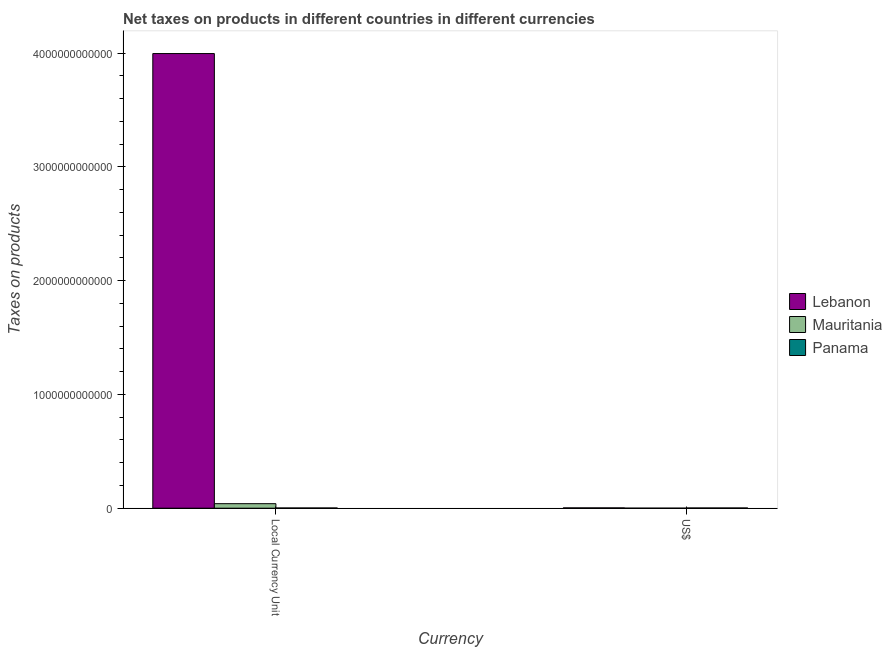Are the number of bars on each tick of the X-axis equal?
Make the answer very short. Yes. What is the label of the 1st group of bars from the left?
Offer a terse response. Local Currency Unit. What is the net taxes in constant 2005 us$ in Lebanon?
Your answer should be compact. 4.00e+12. Across all countries, what is the maximum net taxes in us$?
Your response must be concise. 2.65e+09. Across all countries, what is the minimum net taxes in constant 2005 us$?
Make the answer very short. 1.88e+09. In which country was the net taxes in us$ maximum?
Provide a succinct answer. Lebanon. In which country was the net taxes in us$ minimum?
Offer a very short reply. Mauritania. What is the total net taxes in constant 2005 us$ in the graph?
Offer a terse response. 4.04e+12. What is the difference between the net taxes in us$ in Lebanon and that in Mauritania?
Make the answer very short. 2.50e+09. What is the difference between the net taxes in us$ in Lebanon and the net taxes in constant 2005 us$ in Panama?
Keep it short and to the point. 7.70e+08. What is the average net taxes in constant 2005 us$ per country?
Keep it short and to the point. 1.35e+12. What is the difference between the net taxes in us$ and net taxes in constant 2005 us$ in Mauritania?
Your answer should be very brief. -3.95e+1. What is the ratio of the net taxes in constant 2005 us$ in Mauritania to that in Lebanon?
Provide a succinct answer. 0.01. In how many countries, is the net taxes in us$ greater than the average net taxes in us$ taken over all countries?
Your answer should be compact. 2. What does the 3rd bar from the left in Local Currency Unit represents?
Provide a short and direct response. Panama. What does the 3rd bar from the right in US$ represents?
Your answer should be compact. Lebanon. How many bars are there?
Keep it short and to the point. 6. Are all the bars in the graph horizontal?
Make the answer very short. No. How many countries are there in the graph?
Your response must be concise. 3. What is the difference between two consecutive major ticks on the Y-axis?
Offer a terse response. 1.00e+12. Does the graph contain any zero values?
Your response must be concise. No. Where does the legend appear in the graph?
Provide a succinct answer. Center right. What is the title of the graph?
Ensure brevity in your answer.  Net taxes on products in different countries in different currencies. What is the label or title of the X-axis?
Offer a very short reply. Currency. What is the label or title of the Y-axis?
Make the answer very short. Taxes on products. What is the Taxes on products in Lebanon in Local Currency Unit?
Ensure brevity in your answer.  4.00e+12. What is the Taxes on products of Mauritania in Local Currency Unit?
Offer a very short reply. 3.97e+1. What is the Taxes on products in Panama in Local Currency Unit?
Your answer should be compact. 1.88e+09. What is the Taxes on products of Lebanon in US$?
Make the answer very short. 2.65e+09. What is the Taxes on products in Mauritania in US$?
Offer a very short reply. 1.50e+08. What is the Taxes on products of Panama in US$?
Offer a very short reply. 1.88e+09. Across all Currency, what is the maximum Taxes on products of Lebanon?
Provide a short and direct response. 4.00e+12. Across all Currency, what is the maximum Taxes on products of Mauritania?
Offer a very short reply. 3.97e+1. Across all Currency, what is the maximum Taxes on products in Panama?
Your answer should be very brief. 1.88e+09. Across all Currency, what is the minimum Taxes on products in Lebanon?
Ensure brevity in your answer.  2.65e+09. Across all Currency, what is the minimum Taxes on products in Mauritania?
Provide a succinct answer. 1.50e+08. Across all Currency, what is the minimum Taxes on products of Panama?
Make the answer very short. 1.88e+09. What is the total Taxes on products of Lebanon in the graph?
Give a very brief answer. 4.00e+12. What is the total Taxes on products of Mauritania in the graph?
Your response must be concise. 3.98e+1. What is the total Taxes on products in Panama in the graph?
Your response must be concise. 3.76e+09. What is the difference between the Taxes on products in Lebanon in Local Currency Unit and that in US$?
Your response must be concise. 3.99e+12. What is the difference between the Taxes on products in Mauritania in Local Currency Unit and that in US$?
Give a very brief answer. 3.95e+1. What is the difference between the Taxes on products of Panama in Local Currency Unit and that in US$?
Your answer should be compact. 0. What is the difference between the Taxes on products of Lebanon in Local Currency Unit and the Taxes on products of Mauritania in US$?
Offer a very short reply. 4.00e+12. What is the difference between the Taxes on products in Lebanon in Local Currency Unit and the Taxes on products in Panama in US$?
Offer a very short reply. 4.00e+12. What is the difference between the Taxes on products of Mauritania in Local Currency Unit and the Taxes on products of Panama in US$?
Your answer should be very brief. 3.78e+1. What is the average Taxes on products of Lebanon per Currency?
Provide a short and direct response. 2.00e+12. What is the average Taxes on products in Mauritania per Currency?
Provide a succinct answer. 1.99e+1. What is the average Taxes on products in Panama per Currency?
Provide a succinct answer. 1.88e+09. What is the difference between the Taxes on products of Lebanon and Taxes on products of Mauritania in Local Currency Unit?
Your answer should be compact. 3.96e+12. What is the difference between the Taxes on products of Lebanon and Taxes on products of Panama in Local Currency Unit?
Offer a terse response. 4.00e+12. What is the difference between the Taxes on products in Mauritania and Taxes on products in Panama in Local Currency Unit?
Ensure brevity in your answer.  3.78e+1. What is the difference between the Taxes on products of Lebanon and Taxes on products of Mauritania in US$?
Give a very brief answer. 2.50e+09. What is the difference between the Taxes on products in Lebanon and Taxes on products in Panama in US$?
Make the answer very short. 7.70e+08. What is the difference between the Taxes on products in Mauritania and Taxes on products in Panama in US$?
Offer a very short reply. -1.73e+09. What is the ratio of the Taxes on products in Lebanon in Local Currency Unit to that in US$?
Provide a short and direct response. 1507.5. What is the ratio of the Taxes on products in Mauritania in Local Currency Unit to that in US$?
Your answer should be compact. 265. What is the ratio of the Taxes on products of Panama in Local Currency Unit to that in US$?
Offer a terse response. 1. What is the difference between the highest and the second highest Taxes on products of Lebanon?
Provide a short and direct response. 3.99e+12. What is the difference between the highest and the second highest Taxes on products in Mauritania?
Make the answer very short. 3.95e+1. What is the difference between the highest and the lowest Taxes on products of Lebanon?
Ensure brevity in your answer.  3.99e+12. What is the difference between the highest and the lowest Taxes on products of Mauritania?
Your answer should be compact. 3.95e+1. What is the difference between the highest and the lowest Taxes on products of Panama?
Provide a succinct answer. 0. 